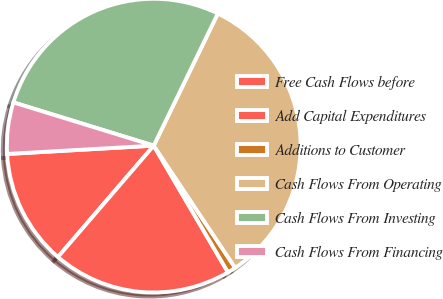Convert chart to OTSL. <chart><loc_0><loc_0><loc_500><loc_500><pie_chart><fcel>Free Cash Flows before<fcel>Add Capital Expenditures<fcel>Additions to Customer<fcel>Cash Flows From Operating<fcel>Cash Flows From Investing<fcel>Cash Flows From Financing<nl><fcel>12.79%<fcel>19.74%<fcel>0.92%<fcel>33.45%<fcel>27.43%<fcel>5.66%<nl></chart> 